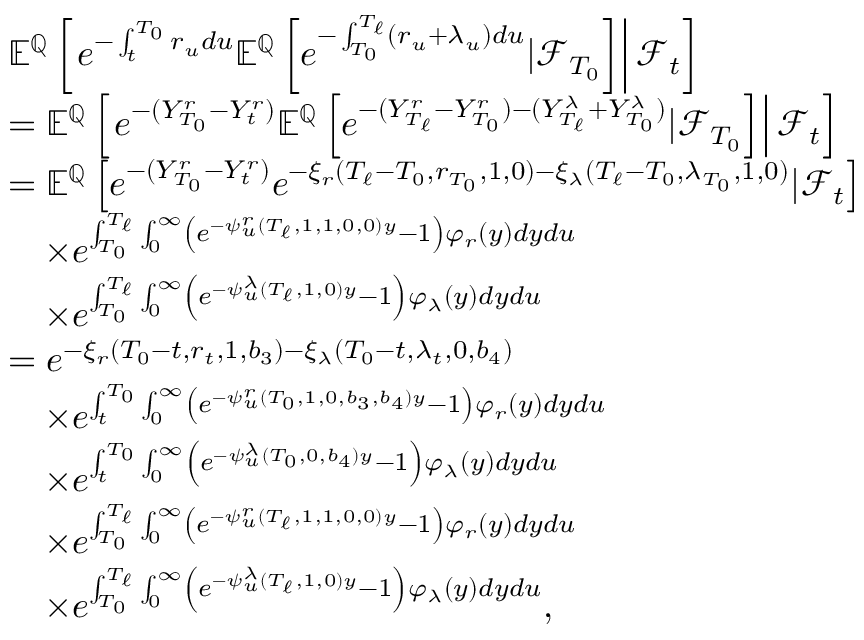Convert formula to latex. <formula><loc_0><loc_0><loc_500><loc_500>\begin{array} { r l } & { { \mathbb { E } } ^ { \mathbb { Q } } \left [ e ^ { - \int _ { t } ^ { T _ { 0 } } r _ { u } d u } { \mathbb { E } } ^ { \mathbb { Q } } \left [ e ^ { - \int _ { T _ { 0 } } ^ { T _ { \ell } } ( r _ { u } + \lambda _ { u } ) d u } | { \mathcal { F } } _ { T _ { 0 } } \right ] \right | { \mathcal { F } } _ { t } \right ] } \\ & { = { \mathbb { E } } ^ { \mathbb { Q } } \left [ e ^ { - ( Y _ { T _ { 0 } } ^ { r } - Y _ { t } ^ { r } ) } { \mathbb { E } } ^ { \mathbb { Q } } \left [ e ^ { - ( Y _ { T _ { \ell } } ^ { r } - Y _ { T _ { 0 } } ^ { r } ) - ( Y _ { T _ { \ell } } ^ { \lambda } + Y _ { T _ { 0 } } ^ { \lambda } ) } | { \mathcal { F } } _ { T _ { 0 } } \right ] \right | { \mathcal { F } } _ { t } \right ] } \\ & { = { \mathbb { E } } ^ { \mathbb { Q } } \left [ e ^ { - ( Y _ { T _ { 0 } } ^ { r } - Y _ { t } ^ { r } ) } e ^ { - \xi _ { r } ( T _ { \ell } - T _ { 0 } , r _ { T _ { 0 } } , 1 , 0 ) - \xi _ { \lambda } ( T _ { \ell } - T _ { 0 } , \lambda _ { T _ { 0 } } , 1 , 0 ) } | { \mathcal { F } } _ { t } \right ] } \\ & { \quad t i m e s e ^ { \int _ { T _ { 0 } } ^ { T _ { \ell } } \int _ { 0 } ^ { \infty } \left ( e ^ { - \psi _ { u } ^ { r } ( T _ { \ell } , 1 , 1 , 0 , 0 ) y } - 1 \right ) \varphi _ { r } ( y ) d y d u } } \\ & { \quad t i m e s e ^ { \int _ { T _ { 0 } } ^ { T _ { \ell } } \int _ { 0 } ^ { \infty } \left ( e ^ { - \psi _ { u } ^ { \lambda } ( T _ { \ell } , 1 , 0 ) y } - 1 \right ) \varphi _ { \lambda } ( y ) d y d u } } \\ & { = e ^ { - \xi _ { r } ( T _ { 0 } - t , r _ { t } , 1 , b _ { 3 } ) - \xi _ { \lambda } ( T _ { 0 } - t , \lambda _ { t } , 0 , b _ { 4 } ) } } \\ & { \quad t i m e s e ^ { \int _ { t } ^ { T _ { 0 } } \int _ { 0 } ^ { \infty } \left ( e ^ { - \psi _ { u } ^ { r } ( T _ { 0 } , 1 , 0 , b _ { 3 } , b _ { 4 } ) y } - 1 \right ) \varphi _ { r } ( y ) d y d u } } \\ & { \quad t i m e s e ^ { \int _ { t } ^ { T _ { 0 } } \int _ { 0 } ^ { \infty } \left ( e ^ { - \psi _ { u } ^ { \lambda } ( T _ { 0 } , 0 , b _ { 4 } ) y } - 1 \right ) \varphi _ { \lambda } ( y ) d y d u } } \\ & { \quad t i m e s e ^ { \int _ { T _ { 0 } } ^ { T _ { \ell } } \int _ { 0 } ^ { \infty } \left ( e ^ { - \psi _ { u } ^ { r } ( T _ { \ell } , 1 , 1 , 0 , 0 ) y } - 1 \right ) \varphi _ { r } ( y ) d y d u } } \\ & { \quad t i m e s e ^ { \int _ { T _ { 0 } } ^ { T _ { \ell } } \int _ { 0 } ^ { \infty } \left ( e ^ { - \psi _ { u } ^ { \lambda } ( T _ { \ell } , 1 , 0 ) y } - 1 \right ) \varphi _ { \lambda } ( y ) d y d u } , } \end{array}</formula> 